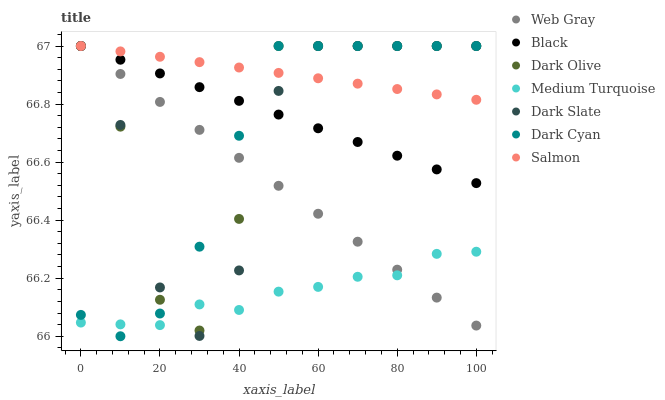Does Medium Turquoise have the minimum area under the curve?
Answer yes or no. Yes. Does Salmon have the maximum area under the curve?
Answer yes or no. Yes. Does Dark Olive have the minimum area under the curve?
Answer yes or no. No. Does Dark Olive have the maximum area under the curve?
Answer yes or no. No. Is Web Gray the smoothest?
Answer yes or no. Yes. Is Dark Olive the roughest?
Answer yes or no. Yes. Is Salmon the smoothest?
Answer yes or no. No. Is Salmon the roughest?
Answer yes or no. No. Does Dark Cyan have the lowest value?
Answer yes or no. Yes. Does Dark Olive have the lowest value?
Answer yes or no. No. Does Dark Cyan have the highest value?
Answer yes or no. Yes. Does Medium Turquoise have the highest value?
Answer yes or no. No. Is Medium Turquoise less than Black?
Answer yes or no. Yes. Is Black greater than Medium Turquoise?
Answer yes or no. Yes. Does Medium Turquoise intersect Dark Olive?
Answer yes or no. Yes. Is Medium Turquoise less than Dark Olive?
Answer yes or no. No. Is Medium Turquoise greater than Dark Olive?
Answer yes or no. No. Does Medium Turquoise intersect Black?
Answer yes or no. No. 